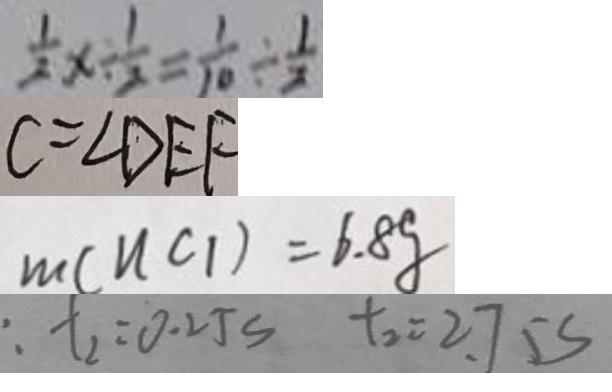Convert formula to latex. <formula><loc_0><loc_0><loc_500><loc_500>\frac { 1 } { 2 } x \div \frac { 1 } { 2 } = \frac { 1 } { 1 0 } \div \frac { 1 } { 2 } 
 C = \angle D E F 
 m ( n c _ { 1 } ) = 6 . 8 g 
 : t _ { 2 } = 0 . 2 5 s t _ { 2 } = 2 . 7 5 s</formula> 